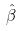Convert formula to latex. <formula><loc_0><loc_0><loc_500><loc_500>\hat { \beta }</formula> 